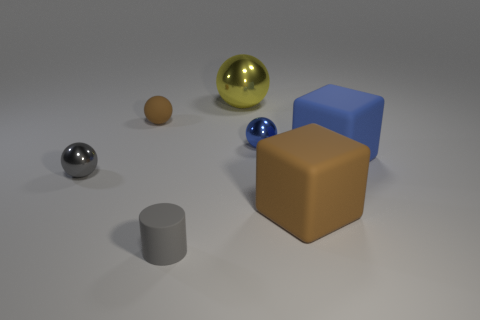Can you describe the different materials that the objects in this image seem to be made of? Certainly! The objects in the image appear to exhibit a variety of materials. The largest object, a brown cube, has a matte surface that could be interpreted as a kind of synthetic or wooden material. The blue cube appears to have a plastic-like quality, given its smooth surface and slightly reflective quality. The spherical objects vary as well—where the large gold sphere seems metallic with a reflective finish, the smaller gray and blue spheres may be made of metal or plastic due to their reflective characteristics. The brown sphere's non-reflective, uniform surface suggests it could be rubber. Lastly, the cylinder on the left looks like it could be made of ceramic or stone, considering its matte and slightly textured finish. 